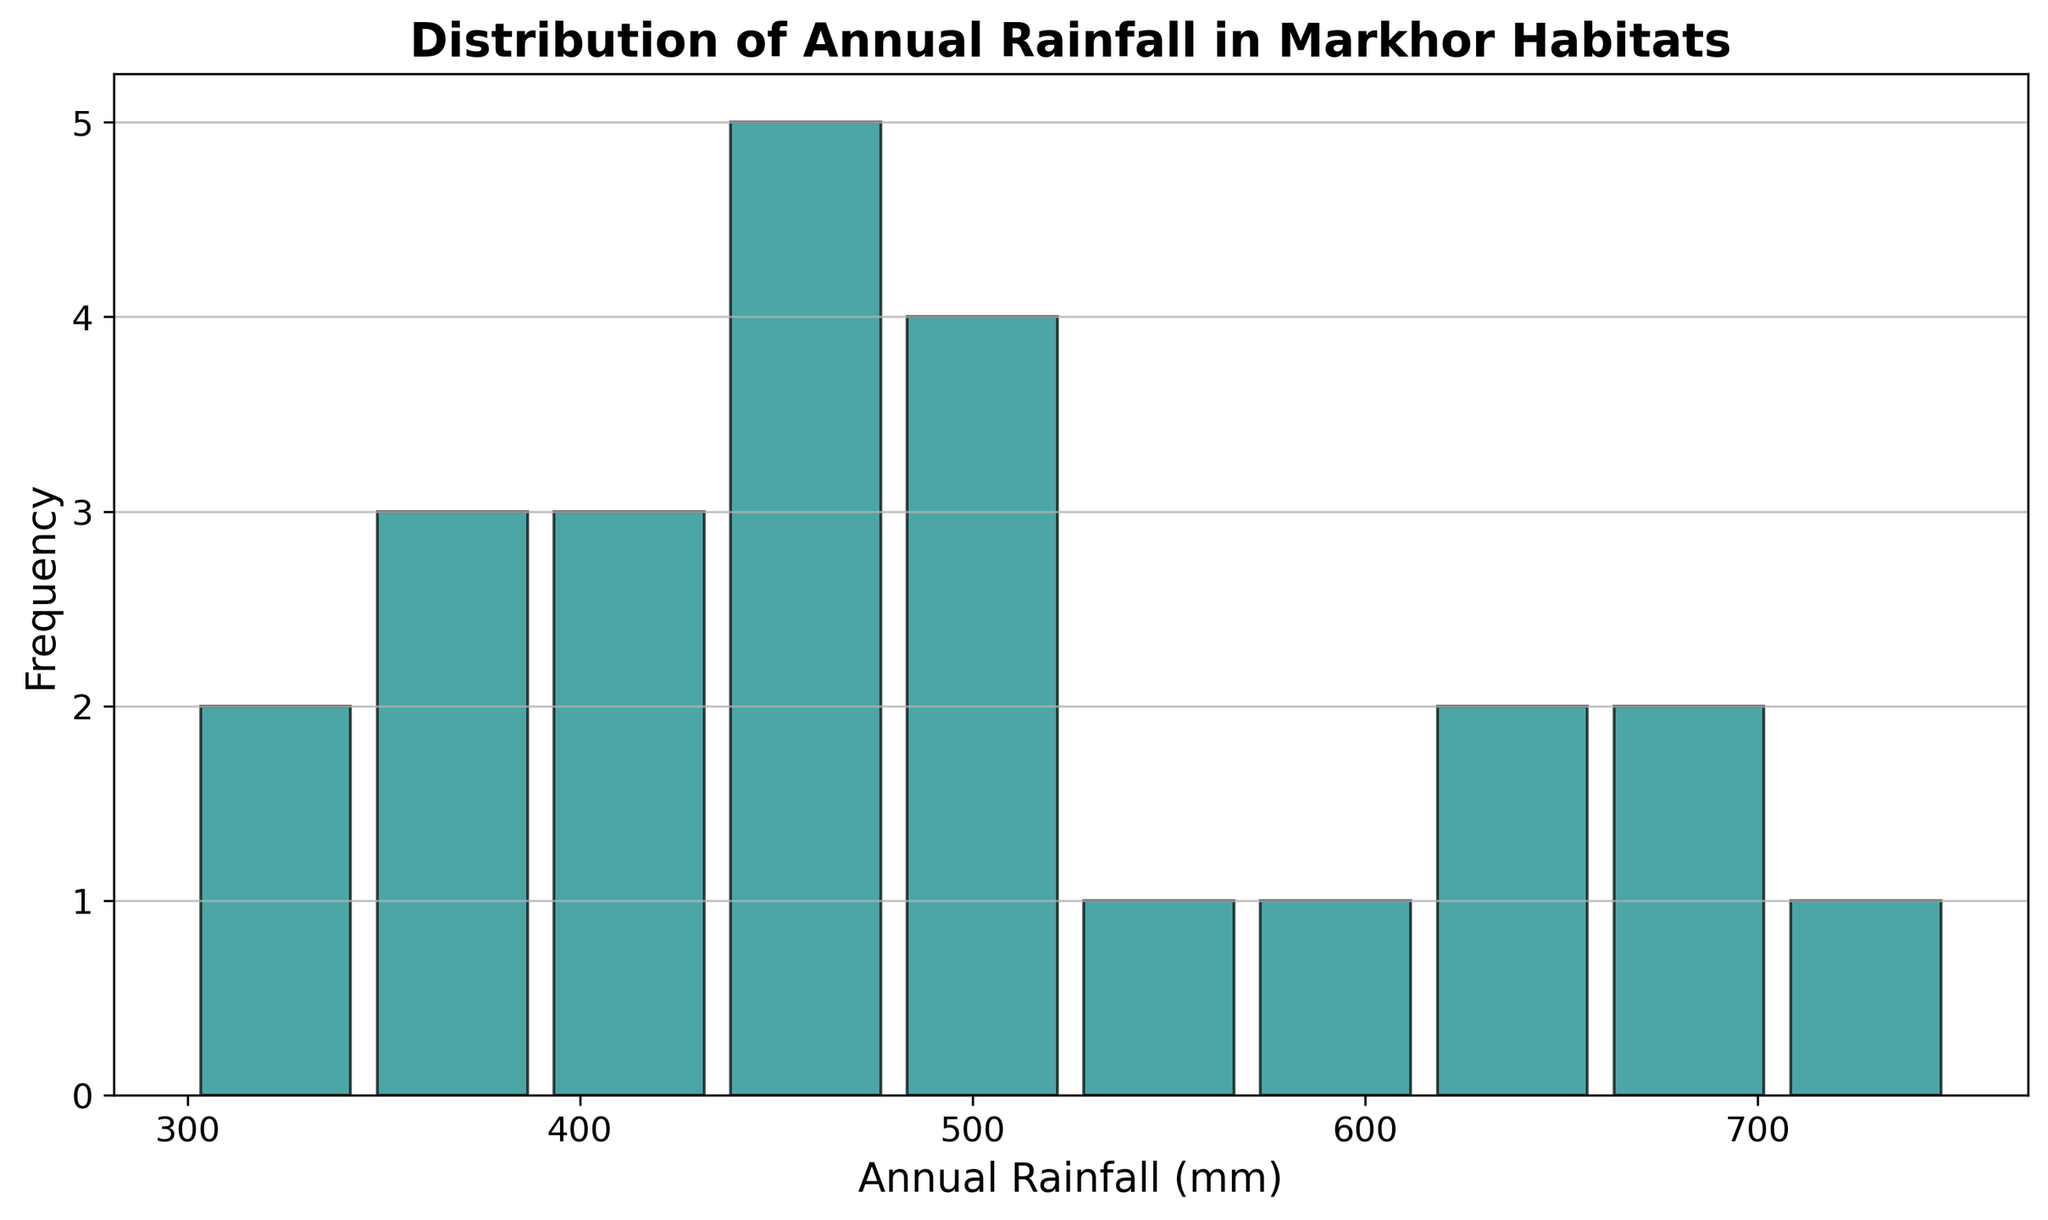Which rainfall range has the highest frequency? Looking at the histogram, the bar representing the highest frequency is the tallest. By referring to the x-axis, we can determine the rainfall range corresponding to that bar.
Answer: 400-450 mm How many habitats experience an annual rainfall between 300 and 350 mm? To answer this, we locate the bar on the x-axis that corresponds to the range of 300 to 350 mm and read its height on the y-axis, which represents the frequency.
Answer: 2 What is the total number of habitats with annual rainfall either less than 350 mm or more than 600 mm? We need to sum the frequencies of bars representing the ranges less than 350 mm and the ranges more than 600 mm. Count the habitats in the first few bars for the lower range and the last few bars for the higher range and add them up.
Answer: 5 Which rainfall range is the least frequent? The smallest bar in the histogram represents the range with the least frequency. By referring to the x-axis and identifying the range corresponding to this smallest bar, we find the answer.
Answer: 300-350 mm What is the mid-point of the most frequent rainfall range? The mid-point can be calculated by taking the average of the lower and upper bounds of the most frequent class interval (400-450 mm). Mid-point = (400 + 450) / 2.
Answer: 425 mm How many habitats receive annual rainfall between 450 mm and 550 mm? To determine this, find the bars corresponding to the 450-500 mm and 500-550 mm ranges. Sum the heights of these bars on the y-axis.
Answer: 5 Is there more variation in habitats receiving less than 500 mm or more than 500 mm of rainfall annually? By visually comparing the spread and heights of bars on either side of the 500 mm mark, we can determine where the distribution shows more variation.
Answer: More than 500 mm What is the average annual rainfall of habitats in the highest frequency range? The highest frequency range is identified as 400-450 mm. To find the average of this range, we take the mean of its lower and upper bounds. Average = (400 + 450) / 2.
Answer: 425 mm 